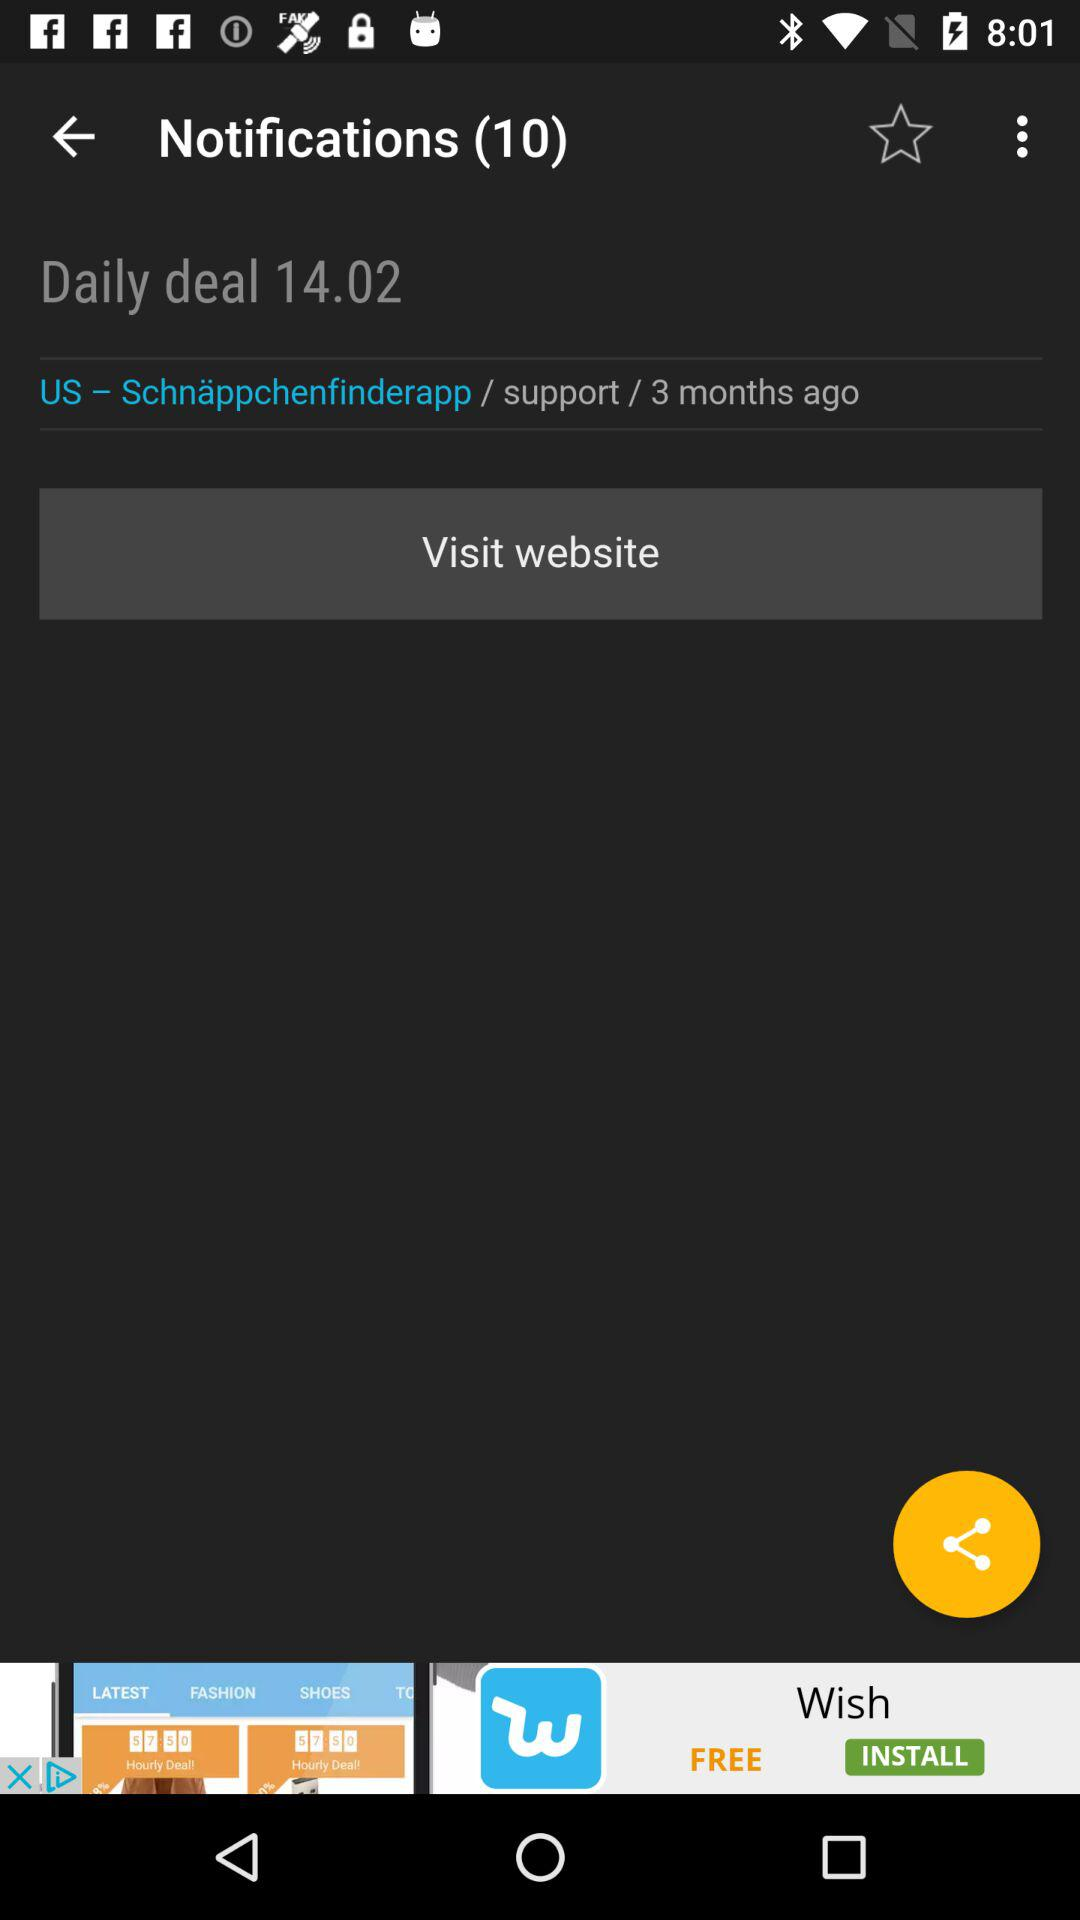What is the total number of notifications? The total number of notifications is 10. 